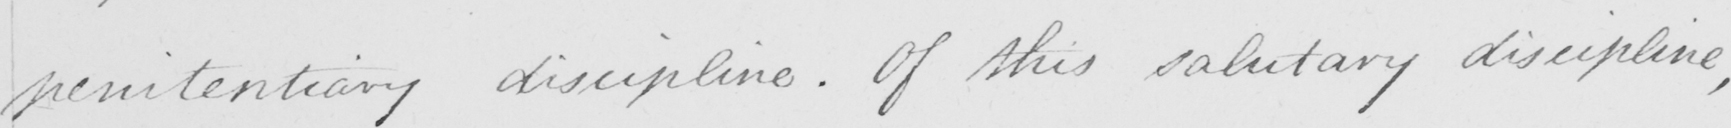Please transcribe the handwritten text in this image. penitentiary discipline . Of this salutary discipline , 